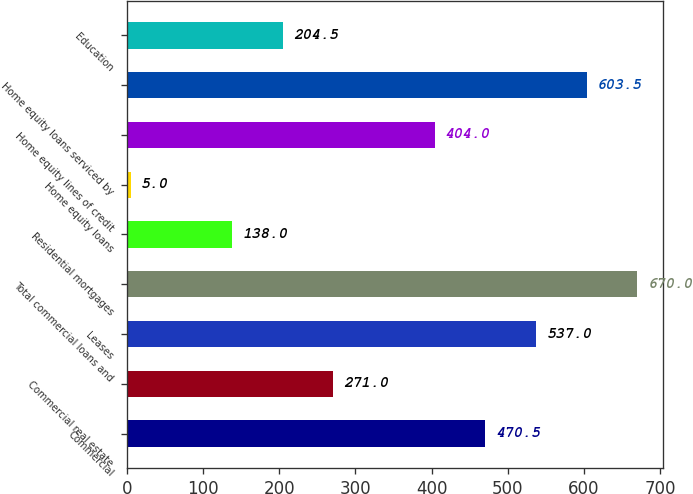Convert chart to OTSL. <chart><loc_0><loc_0><loc_500><loc_500><bar_chart><fcel>Commercial<fcel>Commercial real estate<fcel>Leases<fcel>Total commercial loans and<fcel>Residential mortgages<fcel>Home equity loans<fcel>Home equity lines of credit<fcel>Home equity loans serviced by<fcel>Education<nl><fcel>470.5<fcel>271<fcel>537<fcel>670<fcel>138<fcel>5<fcel>404<fcel>603.5<fcel>204.5<nl></chart> 